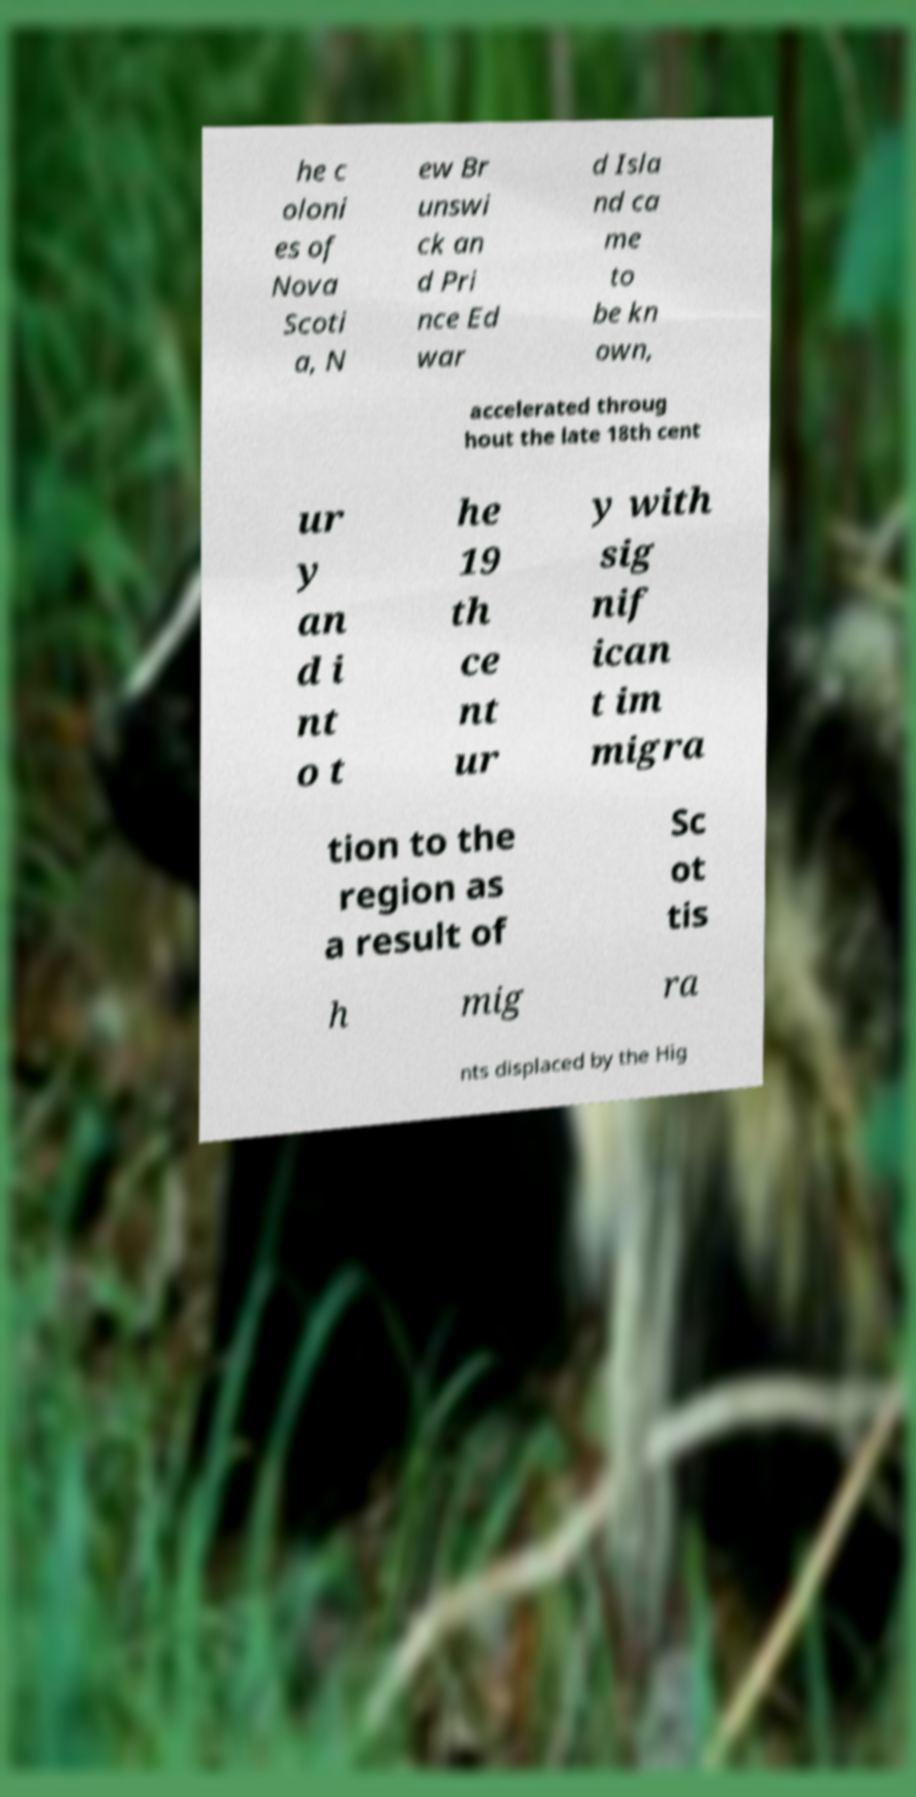There's text embedded in this image that I need extracted. Can you transcribe it verbatim? he c oloni es of Nova Scoti a, N ew Br unswi ck an d Pri nce Ed war d Isla nd ca me to be kn own, accelerated throug hout the late 18th cent ur y an d i nt o t he 19 th ce nt ur y with sig nif ican t im migra tion to the region as a result of Sc ot tis h mig ra nts displaced by the Hig 